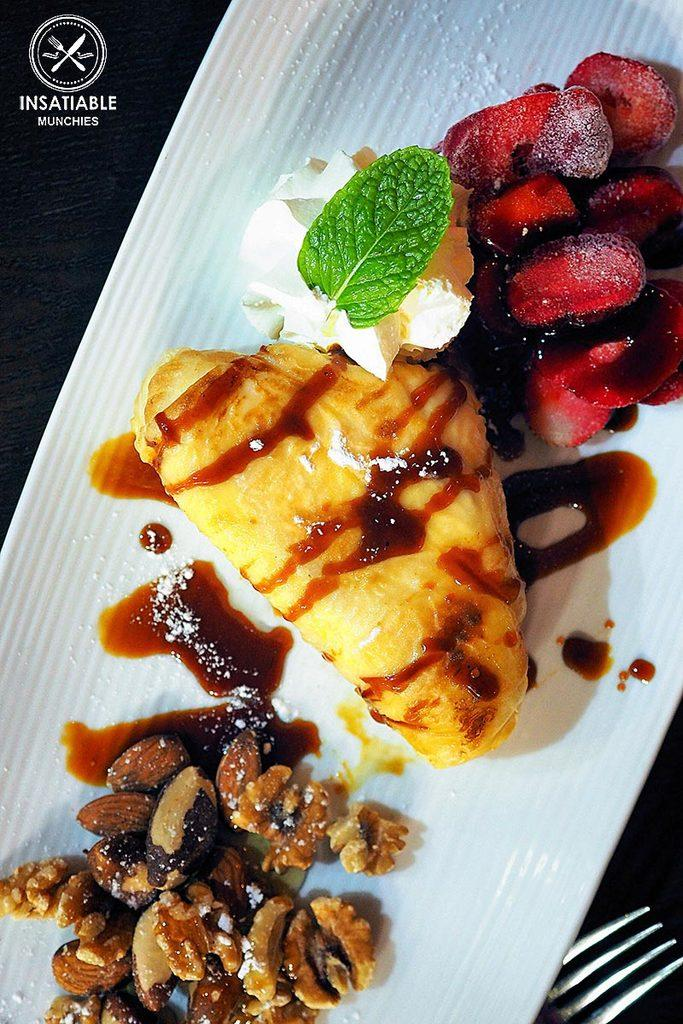What is the main subject of the image? There is a food item in the image. What is the color of the surface on which the food item is placed? The food item is on a white surface. Where is the fork located in the image? The fork is in the bottom right corner of the image. What type of vessel is being used to test the food item in the image? There is no vessel or testing process depicted in the image; it simply shows a food item on a white surface with a fork in the bottom right corner. 